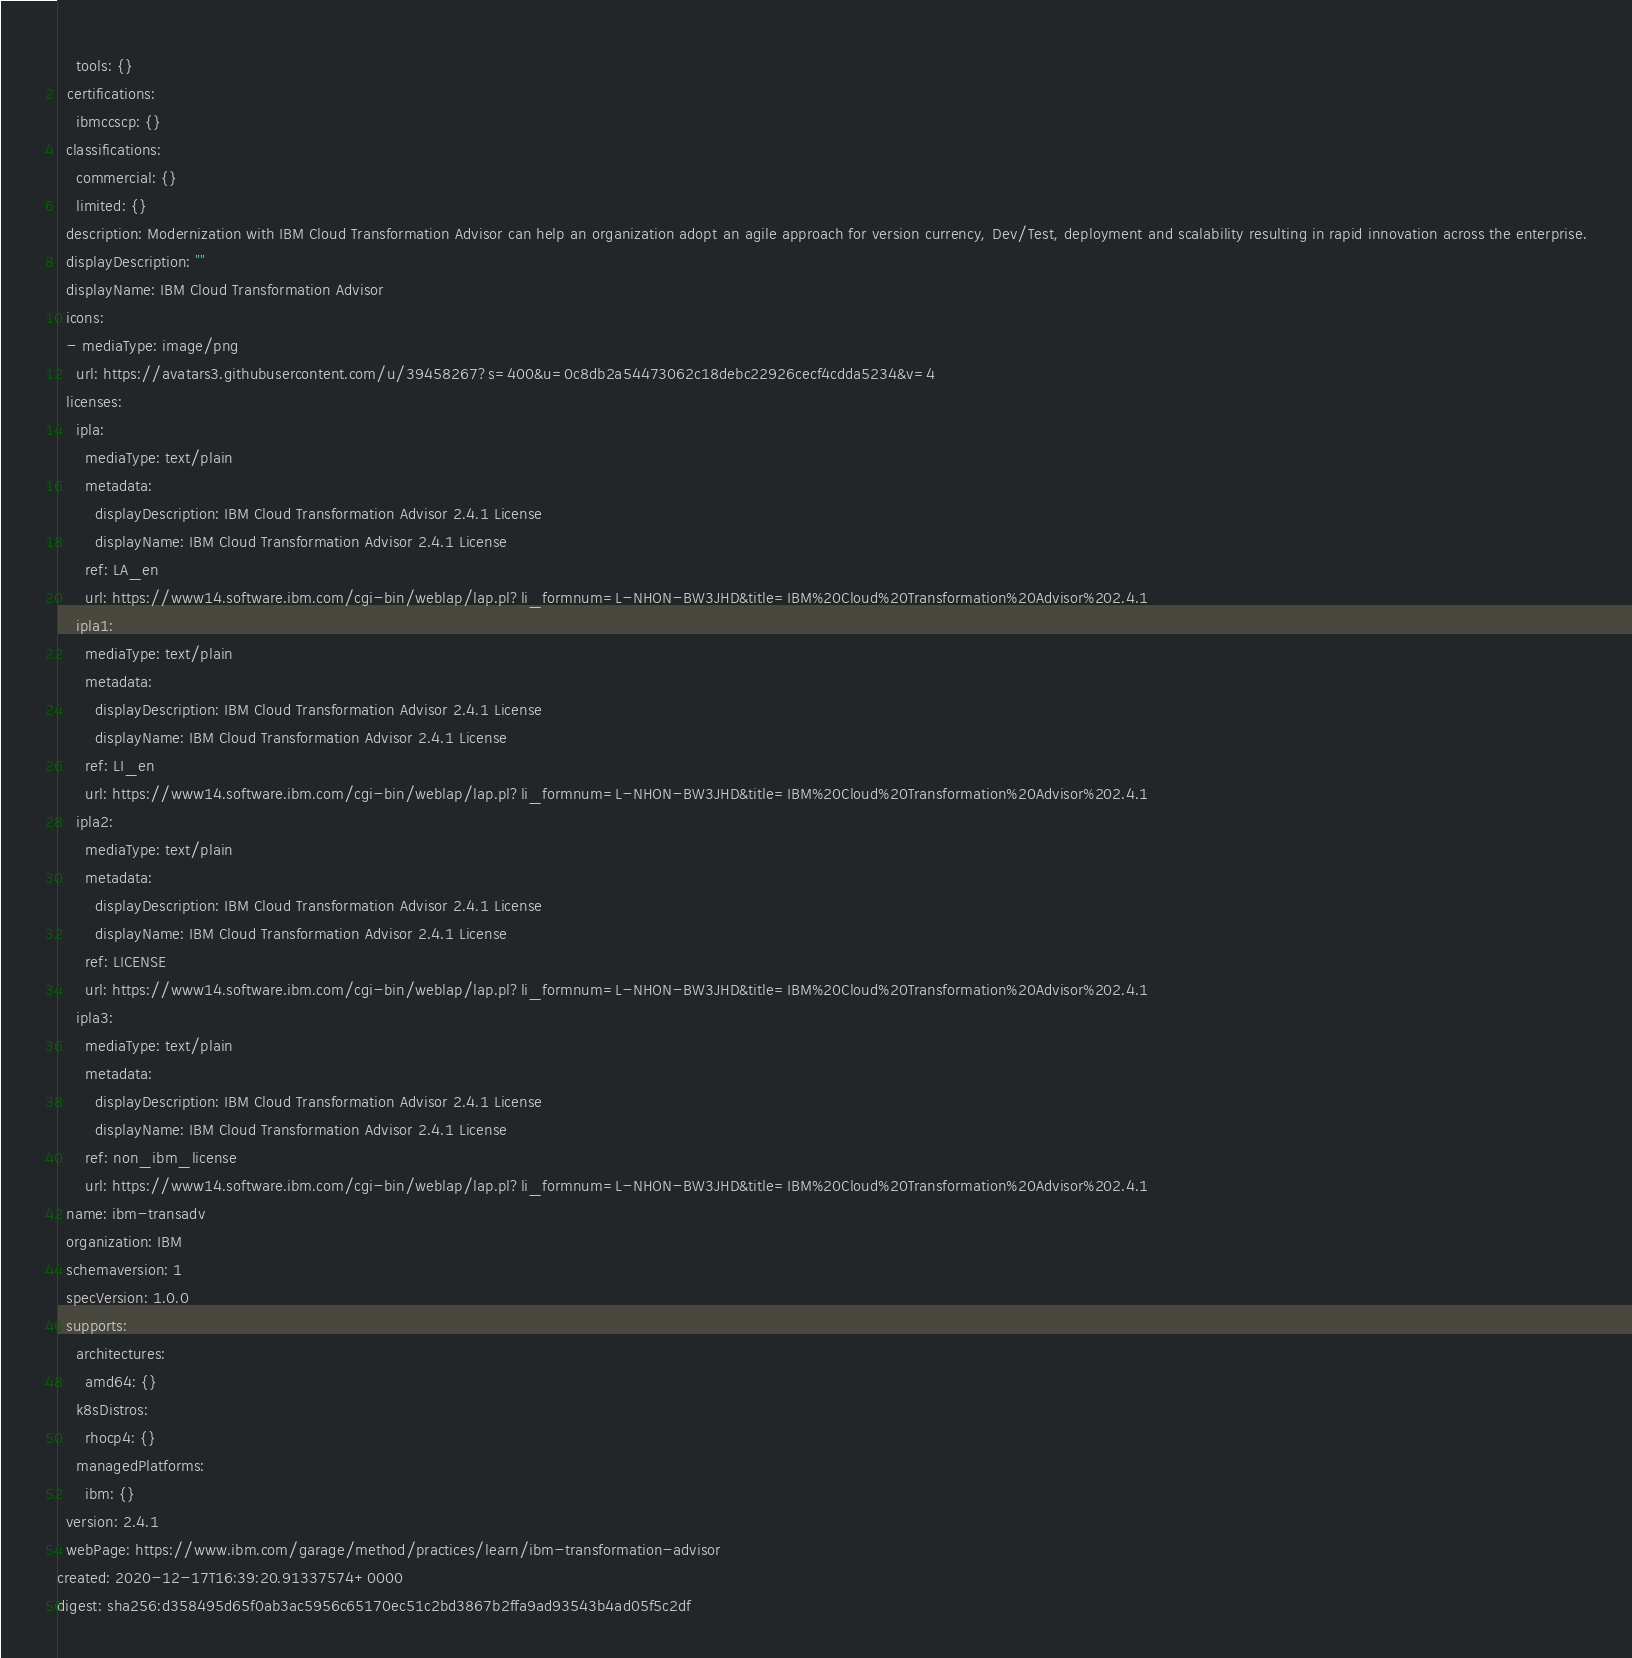Convert code to text. <code><loc_0><loc_0><loc_500><loc_500><_YAML_>    tools: {}
  certifications:
    ibmccscp: {}
  classifications:
    commercial: {}
    limited: {}
  description: Modernization with IBM Cloud Transformation Advisor can help an organization adopt an agile approach for version currency, Dev/Test, deployment and scalability resulting in rapid innovation across the enterprise.
  displayDescription: ""
  displayName: IBM Cloud Transformation Advisor
  icons:
  - mediaType: image/png
    url: https://avatars3.githubusercontent.com/u/39458267?s=400&u=0c8db2a54473062c18debc22926cecf4cdda5234&v=4
  licenses:
    ipla:
      mediaType: text/plain
      metadata:
        displayDescription: IBM Cloud Transformation Advisor 2.4.1 License
        displayName: IBM Cloud Transformation Advisor 2.4.1 License
      ref: LA_en
      url: https://www14.software.ibm.com/cgi-bin/weblap/lap.pl?li_formnum=L-NHON-BW3JHD&title=IBM%20Cloud%20Transformation%20Advisor%202.4.1
    ipla1:
      mediaType: text/plain
      metadata:
        displayDescription: IBM Cloud Transformation Advisor 2.4.1 License
        displayName: IBM Cloud Transformation Advisor 2.4.1 License
      ref: LI_en
      url: https://www14.software.ibm.com/cgi-bin/weblap/lap.pl?li_formnum=L-NHON-BW3JHD&title=IBM%20Cloud%20Transformation%20Advisor%202.4.1
    ipla2:
      mediaType: text/plain
      metadata:
        displayDescription: IBM Cloud Transformation Advisor 2.4.1 License
        displayName: IBM Cloud Transformation Advisor 2.4.1 License
      ref: LICENSE
      url: https://www14.software.ibm.com/cgi-bin/weblap/lap.pl?li_formnum=L-NHON-BW3JHD&title=IBM%20Cloud%20Transformation%20Advisor%202.4.1
    ipla3:
      mediaType: text/plain
      metadata:
        displayDescription: IBM Cloud Transformation Advisor 2.4.1 License
        displayName: IBM Cloud Transformation Advisor 2.4.1 License
      ref: non_ibm_license
      url: https://www14.software.ibm.com/cgi-bin/weblap/lap.pl?li_formnum=L-NHON-BW3JHD&title=IBM%20Cloud%20Transformation%20Advisor%202.4.1
  name: ibm-transadv
  organization: IBM
  schemaversion: 1
  specVersion: 1.0.0
  supports:
    architectures:
      amd64: {}
    k8sDistros:
      rhocp4: {}
    managedPlatforms:
      ibm: {}
  version: 2.4.1
  webPage: https://www.ibm.com/garage/method/practices/learn/ibm-transformation-advisor
created: 2020-12-17T16:39:20.91337574+0000
digest: sha256:d358495d65f0ab3ac5956c65170ec51c2bd3867b2ffa9ad93543b4ad05f5c2df
</code> 